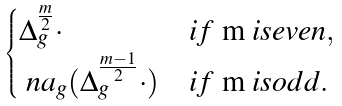Convert formula to latex. <formula><loc_0><loc_0><loc_500><loc_500>\begin{cases} \Delta _ { g } ^ { \frac { m } { 2 } } \cdot & i f $ m $ i s e v e n , \\ \ n a _ { g } ( \Delta _ { g } ^ { \frac { m - 1 } 2 } \cdot ) & i f $ m $ i s o d d . \end{cases}</formula> 